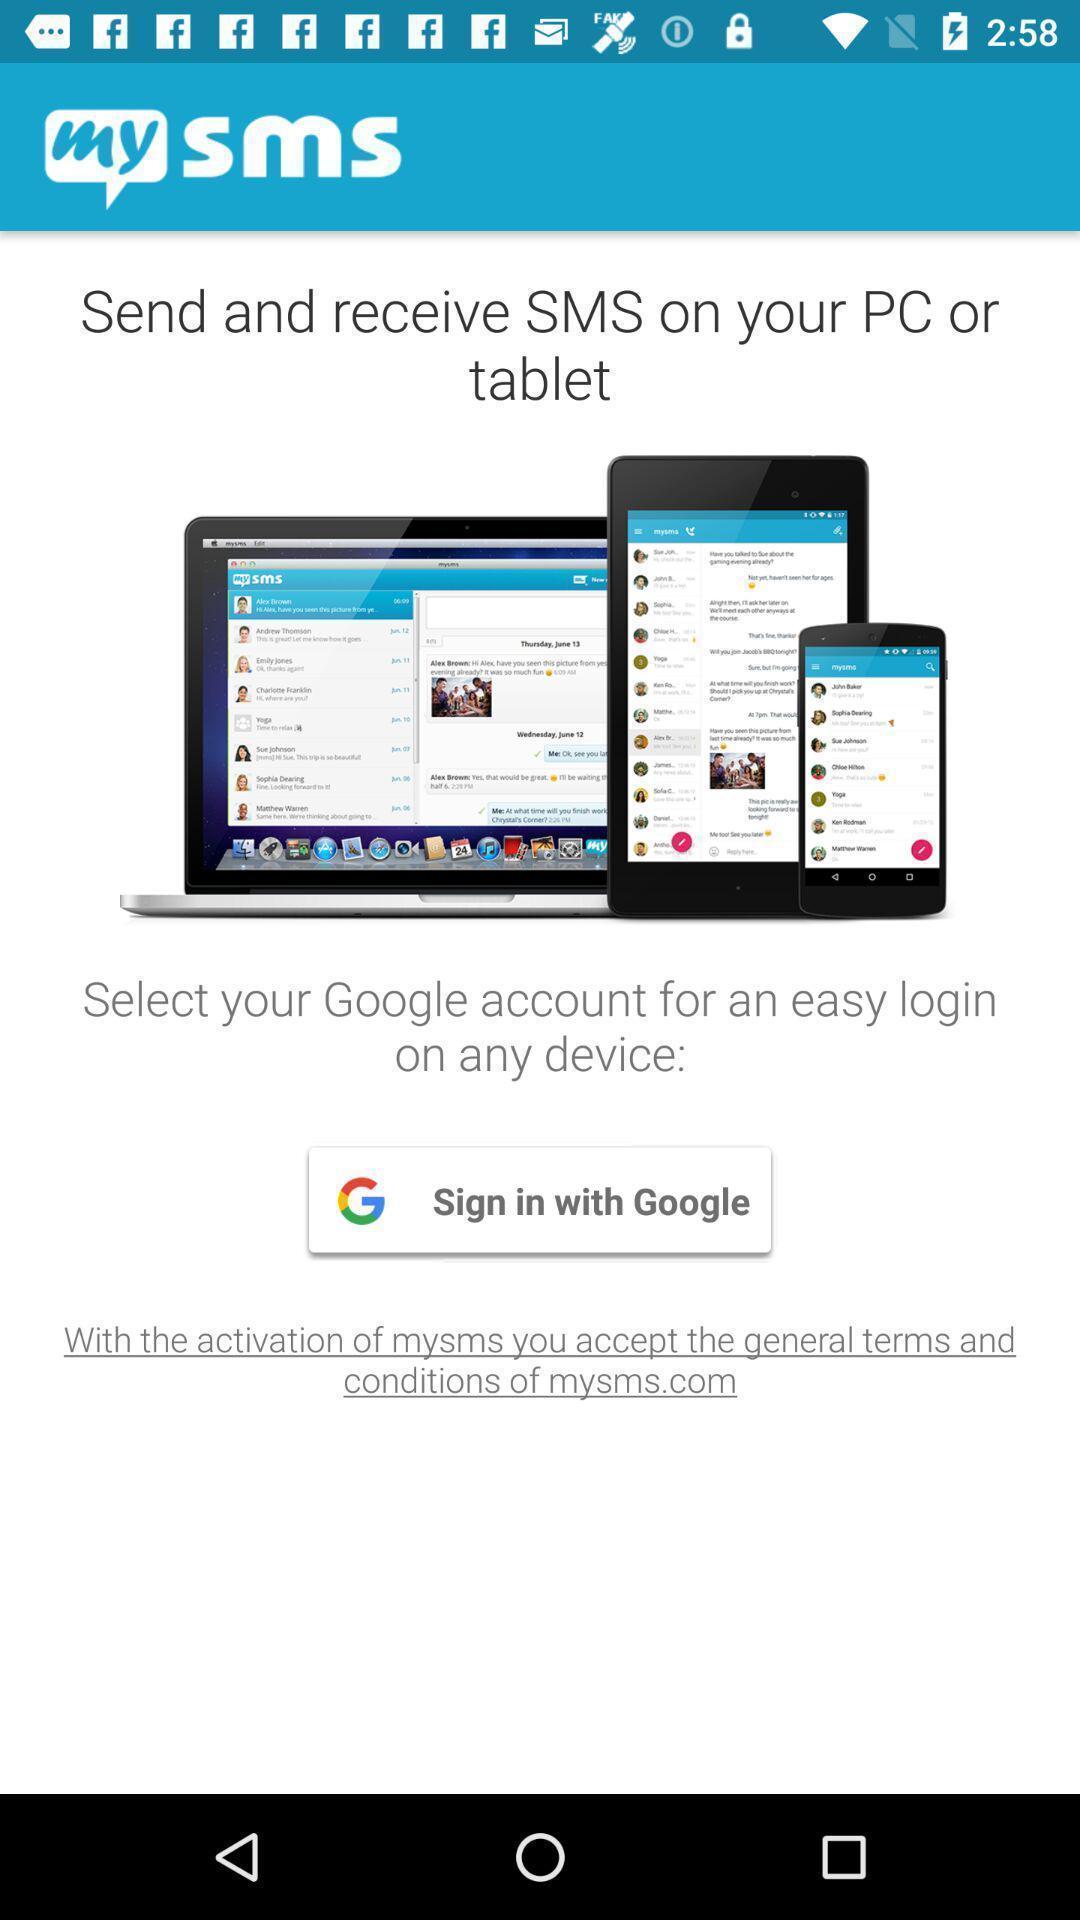Describe the content in this image. Welcome page for an online messaging application. 